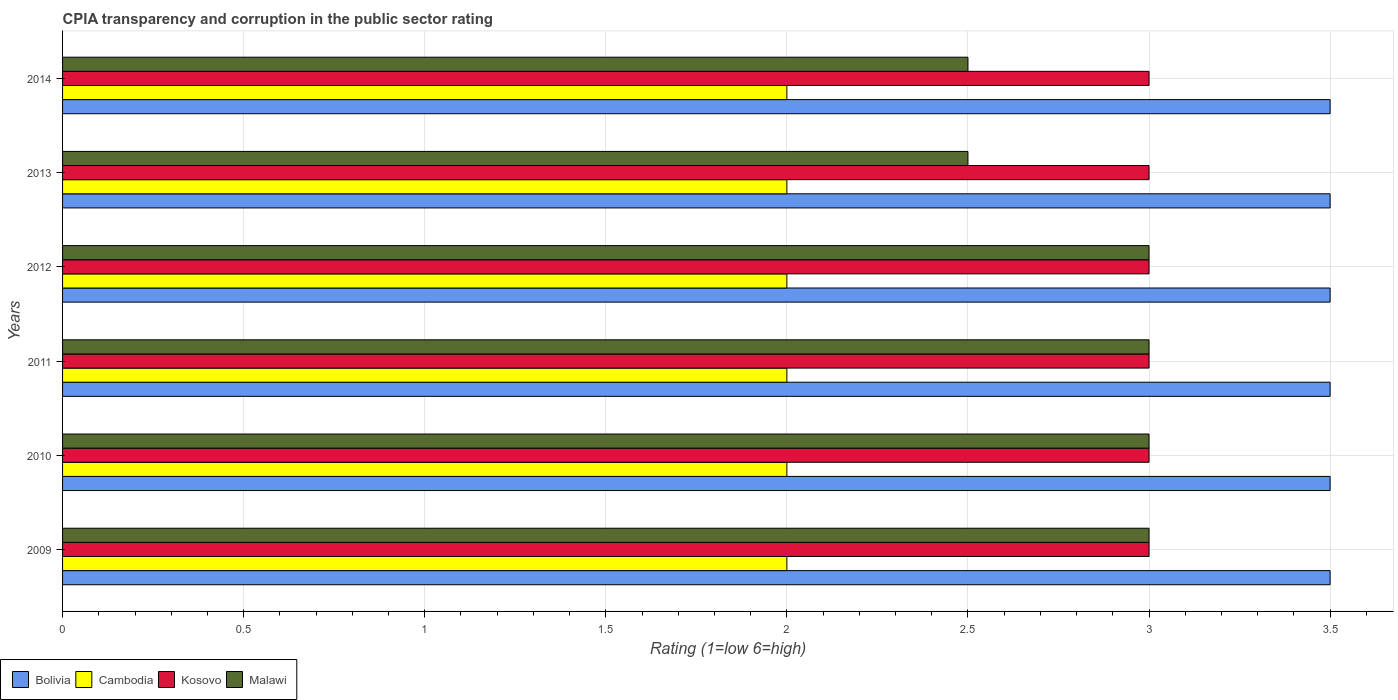How many different coloured bars are there?
Offer a terse response. 4. Are the number of bars on each tick of the Y-axis equal?
Provide a short and direct response. Yes. In how many cases, is the number of bars for a given year not equal to the number of legend labels?
Your answer should be compact. 0. Across all years, what is the minimum CPIA rating in Cambodia?
Keep it short and to the point. 2. In which year was the CPIA rating in Kosovo minimum?
Ensure brevity in your answer.  2009. What is the total CPIA rating in Kosovo in the graph?
Give a very brief answer. 18. What is the difference between the CPIA rating in Malawi in 2009 and that in 2011?
Provide a short and direct response. 0. What is the difference between the CPIA rating in Malawi in 2010 and the CPIA rating in Bolivia in 2014?
Your answer should be very brief. -0.5. What is the average CPIA rating in Cambodia per year?
Keep it short and to the point. 2. What is the difference between the highest and the lowest CPIA rating in Cambodia?
Provide a short and direct response. 0. Is the sum of the CPIA rating in Malawi in 2012 and 2014 greater than the maximum CPIA rating in Bolivia across all years?
Keep it short and to the point. Yes. Is it the case that in every year, the sum of the CPIA rating in Bolivia and CPIA rating in Cambodia is greater than the sum of CPIA rating in Kosovo and CPIA rating in Malawi?
Make the answer very short. No. What does the 4th bar from the top in 2011 represents?
Your answer should be compact. Bolivia. What does the 1st bar from the bottom in 2014 represents?
Offer a very short reply. Bolivia. Is it the case that in every year, the sum of the CPIA rating in Bolivia and CPIA rating in Cambodia is greater than the CPIA rating in Kosovo?
Your response must be concise. Yes. Are all the bars in the graph horizontal?
Provide a succinct answer. Yes. What is the difference between two consecutive major ticks on the X-axis?
Offer a terse response. 0.5. How many legend labels are there?
Offer a very short reply. 4. How are the legend labels stacked?
Offer a very short reply. Horizontal. What is the title of the graph?
Your answer should be compact. CPIA transparency and corruption in the public sector rating. What is the label or title of the X-axis?
Give a very brief answer. Rating (1=low 6=high). What is the Rating (1=low 6=high) of Bolivia in 2009?
Ensure brevity in your answer.  3.5. What is the Rating (1=low 6=high) in Cambodia in 2009?
Your response must be concise. 2. What is the Rating (1=low 6=high) of Kosovo in 2009?
Provide a short and direct response. 3. What is the Rating (1=low 6=high) in Bolivia in 2010?
Your answer should be very brief. 3.5. What is the Rating (1=low 6=high) of Kosovo in 2010?
Your answer should be very brief. 3. What is the Rating (1=low 6=high) of Malawi in 2010?
Give a very brief answer. 3. What is the Rating (1=low 6=high) in Cambodia in 2011?
Make the answer very short. 2. What is the Rating (1=low 6=high) of Malawi in 2011?
Give a very brief answer. 3. What is the Rating (1=low 6=high) in Malawi in 2012?
Offer a very short reply. 3. What is the Rating (1=low 6=high) of Bolivia in 2013?
Make the answer very short. 3.5. What is the Rating (1=low 6=high) in Bolivia in 2014?
Your answer should be very brief. 3.5. What is the Rating (1=low 6=high) in Cambodia in 2014?
Keep it short and to the point. 2. What is the Rating (1=low 6=high) of Kosovo in 2014?
Ensure brevity in your answer.  3. Across all years, what is the maximum Rating (1=low 6=high) in Bolivia?
Ensure brevity in your answer.  3.5. Across all years, what is the maximum Rating (1=low 6=high) of Cambodia?
Provide a short and direct response. 2. Across all years, what is the maximum Rating (1=low 6=high) of Kosovo?
Give a very brief answer. 3. Across all years, what is the maximum Rating (1=low 6=high) of Malawi?
Offer a terse response. 3. Across all years, what is the minimum Rating (1=low 6=high) in Bolivia?
Keep it short and to the point. 3.5. Across all years, what is the minimum Rating (1=low 6=high) of Cambodia?
Make the answer very short. 2. Across all years, what is the minimum Rating (1=low 6=high) in Kosovo?
Your answer should be very brief. 3. What is the total Rating (1=low 6=high) of Kosovo in the graph?
Ensure brevity in your answer.  18. What is the total Rating (1=low 6=high) in Malawi in the graph?
Your answer should be compact. 17. What is the difference between the Rating (1=low 6=high) of Bolivia in 2009 and that in 2010?
Your response must be concise. 0. What is the difference between the Rating (1=low 6=high) in Cambodia in 2009 and that in 2010?
Ensure brevity in your answer.  0. What is the difference between the Rating (1=low 6=high) in Kosovo in 2009 and that in 2010?
Offer a terse response. 0. What is the difference between the Rating (1=low 6=high) of Malawi in 2009 and that in 2010?
Offer a very short reply. 0. What is the difference between the Rating (1=low 6=high) in Cambodia in 2009 and that in 2011?
Provide a short and direct response. 0. What is the difference between the Rating (1=low 6=high) in Kosovo in 2009 and that in 2011?
Provide a succinct answer. 0. What is the difference between the Rating (1=low 6=high) of Malawi in 2009 and that in 2011?
Keep it short and to the point. 0. What is the difference between the Rating (1=low 6=high) of Cambodia in 2009 and that in 2012?
Provide a short and direct response. 0. What is the difference between the Rating (1=low 6=high) of Malawi in 2009 and that in 2012?
Offer a terse response. 0. What is the difference between the Rating (1=low 6=high) of Bolivia in 2009 and that in 2013?
Your response must be concise. 0. What is the difference between the Rating (1=low 6=high) in Cambodia in 2009 and that in 2013?
Ensure brevity in your answer.  0. What is the difference between the Rating (1=low 6=high) of Malawi in 2009 and that in 2013?
Provide a short and direct response. 0.5. What is the difference between the Rating (1=low 6=high) of Kosovo in 2009 and that in 2014?
Offer a very short reply. 0. What is the difference between the Rating (1=low 6=high) in Bolivia in 2010 and that in 2011?
Your response must be concise. 0. What is the difference between the Rating (1=low 6=high) of Cambodia in 2010 and that in 2011?
Offer a terse response. 0. What is the difference between the Rating (1=low 6=high) in Bolivia in 2010 and that in 2012?
Make the answer very short. 0. What is the difference between the Rating (1=low 6=high) of Cambodia in 2010 and that in 2012?
Provide a short and direct response. 0. What is the difference between the Rating (1=low 6=high) of Malawi in 2010 and that in 2012?
Provide a succinct answer. 0. What is the difference between the Rating (1=low 6=high) of Bolivia in 2010 and that in 2013?
Your answer should be very brief. 0. What is the difference between the Rating (1=low 6=high) of Cambodia in 2010 and that in 2013?
Provide a succinct answer. 0. What is the difference between the Rating (1=low 6=high) of Malawi in 2010 and that in 2013?
Your response must be concise. 0.5. What is the difference between the Rating (1=low 6=high) in Cambodia in 2010 and that in 2014?
Provide a short and direct response. 0. What is the difference between the Rating (1=low 6=high) of Kosovo in 2010 and that in 2014?
Your answer should be very brief. 0. What is the difference between the Rating (1=low 6=high) of Kosovo in 2011 and that in 2012?
Keep it short and to the point. 0. What is the difference between the Rating (1=low 6=high) of Bolivia in 2011 and that in 2013?
Provide a succinct answer. 0. What is the difference between the Rating (1=low 6=high) in Cambodia in 2011 and that in 2013?
Your answer should be compact. 0. What is the difference between the Rating (1=low 6=high) of Malawi in 2011 and that in 2013?
Keep it short and to the point. 0.5. What is the difference between the Rating (1=low 6=high) of Bolivia in 2011 and that in 2014?
Keep it short and to the point. 0. What is the difference between the Rating (1=low 6=high) in Cambodia in 2011 and that in 2014?
Offer a terse response. 0. What is the difference between the Rating (1=low 6=high) of Kosovo in 2011 and that in 2014?
Your answer should be compact. 0. What is the difference between the Rating (1=low 6=high) of Cambodia in 2012 and that in 2013?
Keep it short and to the point. 0. What is the difference between the Rating (1=low 6=high) of Kosovo in 2012 and that in 2013?
Your answer should be compact. 0. What is the difference between the Rating (1=low 6=high) in Malawi in 2012 and that in 2014?
Ensure brevity in your answer.  0.5. What is the difference between the Rating (1=low 6=high) of Cambodia in 2013 and that in 2014?
Ensure brevity in your answer.  0. What is the difference between the Rating (1=low 6=high) of Kosovo in 2013 and that in 2014?
Make the answer very short. 0. What is the difference between the Rating (1=low 6=high) of Cambodia in 2009 and the Rating (1=low 6=high) of Malawi in 2010?
Offer a very short reply. -1. What is the difference between the Rating (1=low 6=high) in Kosovo in 2009 and the Rating (1=low 6=high) in Malawi in 2010?
Keep it short and to the point. 0. What is the difference between the Rating (1=low 6=high) of Bolivia in 2009 and the Rating (1=low 6=high) of Kosovo in 2011?
Offer a very short reply. 0.5. What is the difference between the Rating (1=low 6=high) of Bolivia in 2009 and the Rating (1=low 6=high) of Malawi in 2011?
Your response must be concise. 0.5. What is the difference between the Rating (1=low 6=high) in Cambodia in 2009 and the Rating (1=low 6=high) in Kosovo in 2011?
Your answer should be very brief. -1. What is the difference between the Rating (1=low 6=high) in Cambodia in 2009 and the Rating (1=low 6=high) in Malawi in 2011?
Provide a succinct answer. -1. What is the difference between the Rating (1=low 6=high) of Kosovo in 2009 and the Rating (1=low 6=high) of Malawi in 2011?
Give a very brief answer. 0. What is the difference between the Rating (1=low 6=high) in Bolivia in 2009 and the Rating (1=low 6=high) in Malawi in 2012?
Make the answer very short. 0.5. What is the difference between the Rating (1=low 6=high) of Kosovo in 2009 and the Rating (1=low 6=high) of Malawi in 2012?
Keep it short and to the point. 0. What is the difference between the Rating (1=low 6=high) of Cambodia in 2009 and the Rating (1=low 6=high) of Kosovo in 2013?
Your response must be concise. -1. What is the difference between the Rating (1=low 6=high) of Kosovo in 2009 and the Rating (1=low 6=high) of Malawi in 2013?
Give a very brief answer. 0.5. What is the difference between the Rating (1=low 6=high) of Bolivia in 2009 and the Rating (1=low 6=high) of Cambodia in 2014?
Make the answer very short. 1.5. What is the difference between the Rating (1=low 6=high) of Bolivia in 2009 and the Rating (1=low 6=high) of Kosovo in 2014?
Keep it short and to the point. 0.5. What is the difference between the Rating (1=low 6=high) of Bolivia in 2009 and the Rating (1=low 6=high) of Malawi in 2014?
Provide a succinct answer. 1. What is the difference between the Rating (1=low 6=high) in Kosovo in 2009 and the Rating (1=low 6=high) in Malawi in 2014?
Your response must be concise. 0.5. What is the difference between the Rating (1=low 6=high) in Bolivia in 2010 and the Rating (1=low 6=high) in Cambodia in 2011?
Your answer should be very brief. 1.5. What is the difference between the Rating (1=low 6=high) in Bolivia in 2010 and the Rating (1=low 6=high) in Kosovo in 2011?
Your response must be concise. 0.5. What is the difference between the Rating (1=low 6=high) of Bolivia in 2010 and the Rating (1=low 6=high) of Malawi in 2011?
Offer a very short reply. 0.5. What is the difference between the Rating (1=low 6=high) in Cambodia in 2010 and the Rating (1=low 6=high) in Kosovo in 2011?
Offer a terse response. -1. What is the difference between the Rating (1=low 6=high) of Cambodia in 2010 and the Rating (1=low 6=high) of Malawi in 2011?
Offer a very short reply. -1. What is the difference between the Rating (1=low 6=high) of Bolivia in 2010 and the Rating (1=low 6=high) of Kosovo in 2012?
Ensure brevity in your answer.  0.5. What is the difference between the Rating (1=low 6=high) in Bolivia in 2010 and the Rating (1=low 6=high) in Malawi in 2012?
Provide a succinct answer. 0.5. What is the difference between the Rating (1=low 6=high) of Kosovo in 2010 and the Rating (1=low 6=high) of Malawi in 2012?
Your answer should be compact. 0. What is the difference between the Rating (1=low 6=high) in Bolivia in 2010 and the Rating (1=low 6=high) in Kosovo in 2013?
Offer a very short reply. 0.5. What is the difference between the Rating (1=low 6=high) of Cambodia in 2010 and the Rating (1=low 6=high) of Malawi in 2013?
Your response must be concise. -0.5. What is the difference between the Rating (1=low 6=high) of Kosovo in 2010 and the Rating (1=low 6=high) of Malawi in 2013?
Your answer should be compact. 0.5. What is the difference between the Rating (1=low 6=high) in Cambodia in 2010 and the Rating (1=low 6=high) in Malawi in 2014?
Your answer should be very brief. -0.5. What is the difference between the Rating (1=low 6=high) of Bolivia in 2011 and the Rating (1=low 6=high) of Cambodia in 2012?
Provide a short and direct response. 1.5. What is the difference between the Rating (1=low 6=high) of Bolivia in 2011 and the Rating (1=low 6=high) of Malawi in 2012?
Offer a terse response. 0.5. What is the difference between the Rating (1=low 6=high) in Cambodia in 2011 and the Rating (1=low 6=high) in Kosovo in 2012?
Your answer should be compact. -1. What is the difference between the Rating (1=low 6=high) of Kosovo in 2011 and the Rating (1=low 6=high) of Malawi in 2012?
Provide a succinct answer. 0. What is the difference between the Rating (1=low 6=high) of Bolivia in 2011 and the Rating (1=low 6=high) of Kosovo in 2013?
Your answer should be very brief. 0.5. What is the difference between the Rating (1=low 6=high) of Bolivia in 2011 and the Rating (1=low 6=high) of Kosovo in 2014?
Your answer should be very brief. 0.5. What is the difference between the Rating (1=low 6=high) of Cambodia in 2011 and the Rating (1=low 6=high) of Kosovo in 2014?
Keep it short and to the point. -1. What is the difference between the Rating (1=low 6=high) in Kosovo in 2012 and the Rating (1=low 6=high) in Malawi in 2013?
Provide a succinct answer. 0.5. What is the difference between the Rating (1=low 6=high) of Bolivia in 2012 and the Rating (1=low 6=high) of Cambodia in 2014?
Give a very brief answer. 1.5. What is the difference between the Rating (1=low 6=high) of Kosovo in 2012 and the Rating (1=low 6=high) of Malawi in 2014?
Make the answer very short. 0.5. What is the difference between the Rating (1=low 6=high) of Bolivia in 2013 and the Rating (1=low 6=high) of Kosovo in 2014?
Offer a terse response. 0.5. What is the difference between the Rating (1=low 6=high) of Bolivia in 2013 and the Rating (1=low 6=high) of Malawi in 2014?
Your answer should be compact. 1. What is the difference between the Rating (1=low 6=high) in Cambodia in 2013 and the Rating (1=low 6=high) in Malawi in 2014?
Offer a terse response. -0.5. What is the difference between the Rating (1=low 6=high) of Kosovo in 2013 and the Rating (1=low 6=high) of Malawi in 2014?
Your answer should be compact. 0.5. What is the average Rating (1=low 6=high) in Bolivia per year?
Offer a very short reply. 3.5. What is the average Rating (1=low 6=high) of Malawi per year?
Offer a terse response. 2.83. In the year 2009, what is the difference between the Rating (1=low 6=high) of Bolivia and Rating (1=low 6=high) of Kosovo?
Keep it short and to the point. 0.5. In the year 2009, what is the difference between the Rating (1=low 6=high) in Bolivia and Rating (1=low 6=high) in Malawi?
Your response must be concise. 0.5. In the year 2009, what is the difference between the Rating (1=low 6=high) of Cambodia and Rating (1=low 6=high) of Malawi?
Offer a terse response. -1. In the year 2009, what is the difference between the Rating (1=low 6=high) in Kosovo and Rating (1=low 6=high) in Malawi?
Your answer should be compact. 0. In the year 2010, what is the difference between the Rating (1=low 6=high) in Bolivia and Rating (1=low 6=high) in Cambodia?
Your answer should be very brief. 1.5. In the year 2010, what is the difference between the Rating (1=low 6=high) of Bolivia and Rating (1=low 6=high) of Kosovo?
Offer a very short reply. 0.5. In the year 2010, what is the difference between the Rating (1=low 6=high) of Cambodia and Rating (1=low 6=high) of Malawi?
Give a very brief answer. -1. In the year 2010, what is the difference between the Rating (1=low 6=high) in Kosovo and Rating (1=low 6=high) in Malawi?
Your response must be concise. 0. In the year 2011, what is the difference between the Rating (1=low 6=high) of Bolivia and Rating (1=low 6=high) of Cambodia?
Ensure brevity in your answer.  1.5. In the year 2011, what is the difference between the Rating (1=low 6=high) in Bolivia and Rating (1=low 6=high) in Malawi?
Provide a short and direct response. 0.5. In the year 2012, what is the difference between the Rating (1=low 6=high) of Bolivia and Rating (1=low 6=high) of Cambodia?
Your answer should be compact. 1.5. In the year 2012, what is the difference between the Rating (1=low 6=high) of Cambodia and Rating (1=low 6=high) of Malawi?
Ensure brevity in your answer.  -1. In the year 2013, what is the difference between the Rating (1=low 6=high) in Bolivia and Rating (1=low 6=high) in Kosovo?
Make the answer very short. 0.5. In the year 2013, what is the difference between the Rating (1=low 6=high) in Cambodia and Rating (1=low 6=high) in Kosovo?
Give a very brief answer. -1. In the year 2014, what is the difference between the Rating (1=low 6=high) of Bolivia and Rating (1=low 6=high) of Cambodia?
Keep it short and to the point. 1.5. In the year 2014, what is the difference between the Rating (1=low 6=high) in Bolivia and Rating (1=low 6=high) in Kosovo?
Your answer should be very brief. 0.5. In the year 2014, what is the difference between the Rating (1=low 6=high) in Cambodia and Rating (1=low 6=high) in Malawi?
Your response must be concise. -0.5. What is the ratio of the Rating (1=low 6=high) in Bolivia in 2009 to that in 2010?
Offer a terse response. 1. What is the ratio of the Rating (1=low 6=high) in Bolivia in 2009 to that in 2011?
Give a very brief answer. 1. What is the ratio of the Rating (1=low 6=high) in Cambodia in 2009 to that in 2011?
Provide a succinct answer. 1. What is the ratio of the Rating (1=low 6=high) of Cambodia in 2009 to that in 2012?
Ensure brevity in your answer.  1. What is the ratio of the Rating (1=low 6=high) in Cambodia in 2009 to that in 2013?
Offer a terse response. 1. What is the ratio of the Rating (1=low 6=high) of Malawi in 2009 to that in 2013?
Offer a very short reply. 1.2. What is the ratio of the Rating (1=low 6=high) of Bolivia in 2009 to that in 2014?
Give a very brief answer. 1. What is the ratio of the Rating (1=low 6=high) in Malawi in 2009 to that in 2014?
Make the answer very short. 1.2. What is the ratio of the Rating (1=low 6=high) of Bolivia in 2010 to that in 2011?
Ensure brevity in your answer.  1. What is the ratio of the Rating (1=low 6=high) of Kosovo in 2010 to that in 2011?
Your answer should be very brief. 1. What is the ratio of the Rating (1=low 6=high) of Cambodia in 2010 to that in 2012?
Your answer should be compact. 1. What is the ratio of the Rating (1=low 6=high) in Malawi in 2010 to that in 2012?
Ensure brevity in your answer.  1. What is the ratio of the Rating (1=low 6=high) in Bolivia in 2010 to that in 2013?
Offer a very short reply. 1. What is the ratio of the Rating (1=low 6=high) of Kosovo in 2010 to that in 2013?
Provide a short and direct response. 1. What is the ratio of the Rating (1=low 6=high) in Bolivia in 2010 to that in 2014?
Make the answer very short. 1. What is the ratio of the Rating (1=low 6=high) of Cambodia in 2010 to that in 2014?
Make the answer very short. 1. What is the ratio of the Rating (1=low 6=high) in Malawi in 2010 to that in 2014?
Offer a terse response. 1.2. What is the ratio of the Rating (1=low 6=high) in Bolivia in 2011 to that in 2012?
Your response must be concise. 1. What is the ratio of the Rating (1=low 6=high) of Cambodia in 2011 to that in 2013?
Your response must be concise. 1. What is the ratio of the Rating (1=low 6=high) in Cambodia in 2011 to that in 2014?
Give a very brief answer. 1. What is the ratio of the Rating (1=low 6=high) of Bolivia in 2012 to that in 2013?
Keep it short and to the point. 1. What is the ratio of the Rating (1=low 6=high) in Cambodia in 2012 to that in 2013?
Provide a succinct answer. 1. What is the ratio of the Rating (1=low 6=high) in Malawi in 2012 to that in 2014?
Provide a succinct answer. 1.2. What is the ratio of the Rating (1=low 6=high) of Bolivia in 2013 to that in 2014?
Offer a very short reply. 1. What is the ratio of the Rating (1=low 6=high) in Malawi in 2013 to that in 2014?
Keep it short and to the point. 1. What is the difference between the highest and the second highest Rating (1=low 6=high) of Bolivia?
Offer a very short reply. 0. What is the difference between the highest and the lowest Rating (1=low 6=high) in Cambodia?
Give a very brief answer. 0. 